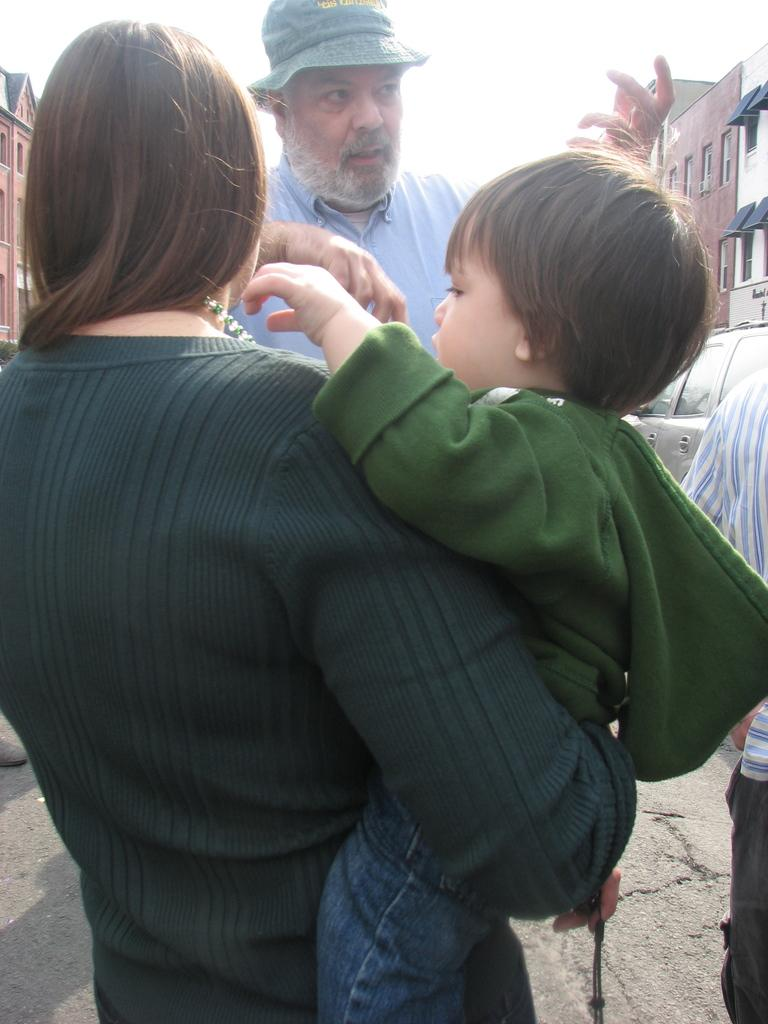What is the woman in the image doing? The woman is holding a baby in the image. Who is the woman interacting with in the image? There is a man standing and speaking to the woman in the image. What can be seen in the background of the image? There are buildings visible in the background of the image. What type of railway can be seen in the image? There is no railway present in the image. Is there a chess game being played in the image? There is no chess game visible in the image. 